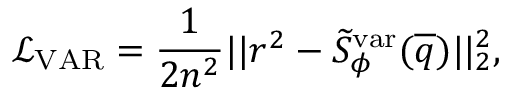<formula> <loc_0><loc_0><loc_500><loc_500>\mathcal { L } _ { V A R } = \frac { 1 } { 2 n ^ { 2 } } | | r ^ { 2 } - \widetilde { S } _ { \phi } ^ { v a r } ( \overline { q } ) | | _ { 2 } ^ { 2 } ,</formula> 